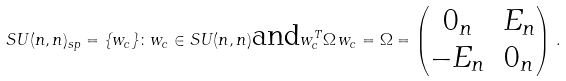<formula> <loc_0><loc_0><loc_500><loc_500>S U ( n , n ) _ { s p } = \{ w _ { c } \} \colon w _ { c } \in S U ( n , n ) \text {and} w _ { c } ^ { T } \Omega \, w _ { c } = \Omega = \begin{pmatrix} 0 _ { n } & E _ { n } \\ - E _ { n } & 0 _ { n } \end{pmatrix} \, .</formula> 